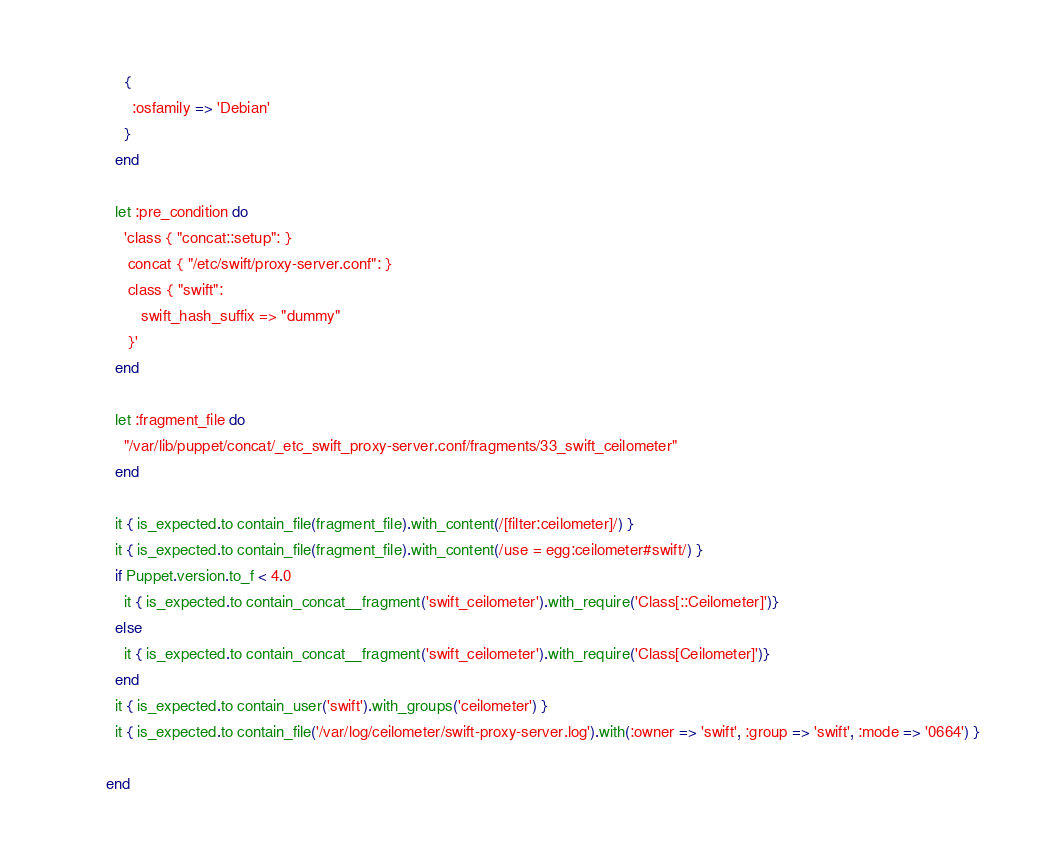<code> <loc_0><loc_0><loc_500><loc_500><_Ruby_>    {
      :osfamily => 'Debian'
    }
  end

  let :pre_condition do
    'class { "concat::setup": }
     concat { "/etc/swift/proxy-server.conf": }
     class { "swift":
        swift_hash_suffix => "dummy"
     }'
  end

  let :fragment_file do
    "/var/lib/puppet/concat/_etc_swift_proxy-server.conf/fragments/33_swift_ceilometer"
  end

  it { is_expected.to contain_file(fragment_file).with_content(/[filter:ceilometer]/) }
  it { is_expected.to contain_file(fragment_file).with_content(/use = egg:ceilometer#swift/) }
  if Puppet.version.to_f < 4.0
    it { is_expected.to contain_concat__fragment('swift_ceilometer').with_require('Class[::Ceilometer]')}
  else
    it { is_expected.to contain_concat__fragment('swift_ceilometer').with_require('Class[Ceilometer]')}
  end
  it { is_expected.to contain_user('swift').with_groups('ceilometer') }
  it { is_expected.to contain_file('/var/log/ceilometer/swift-proxy-server.log').with(:owner => 'swift', :group => 'swift', :mode => '0664') }

end
</code> 